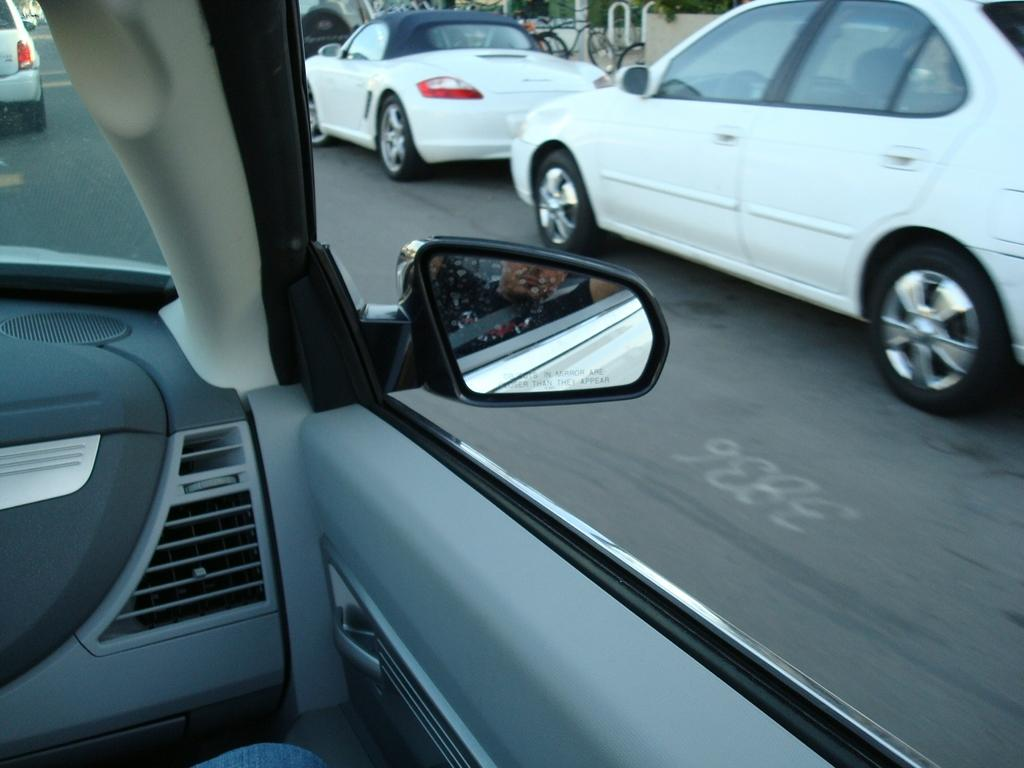What can be seen on the road surface in the image? There are parked cars on the road surface in the image. Where is the image taken from? The image is taken from inside a car. What is visible in front of the image? There is a side mirror of a car in front of the image. What type of meat is being grilled in the image? There is no meat or grill present in the image; it features parked cars on the road surface and a side mirror of a car. 